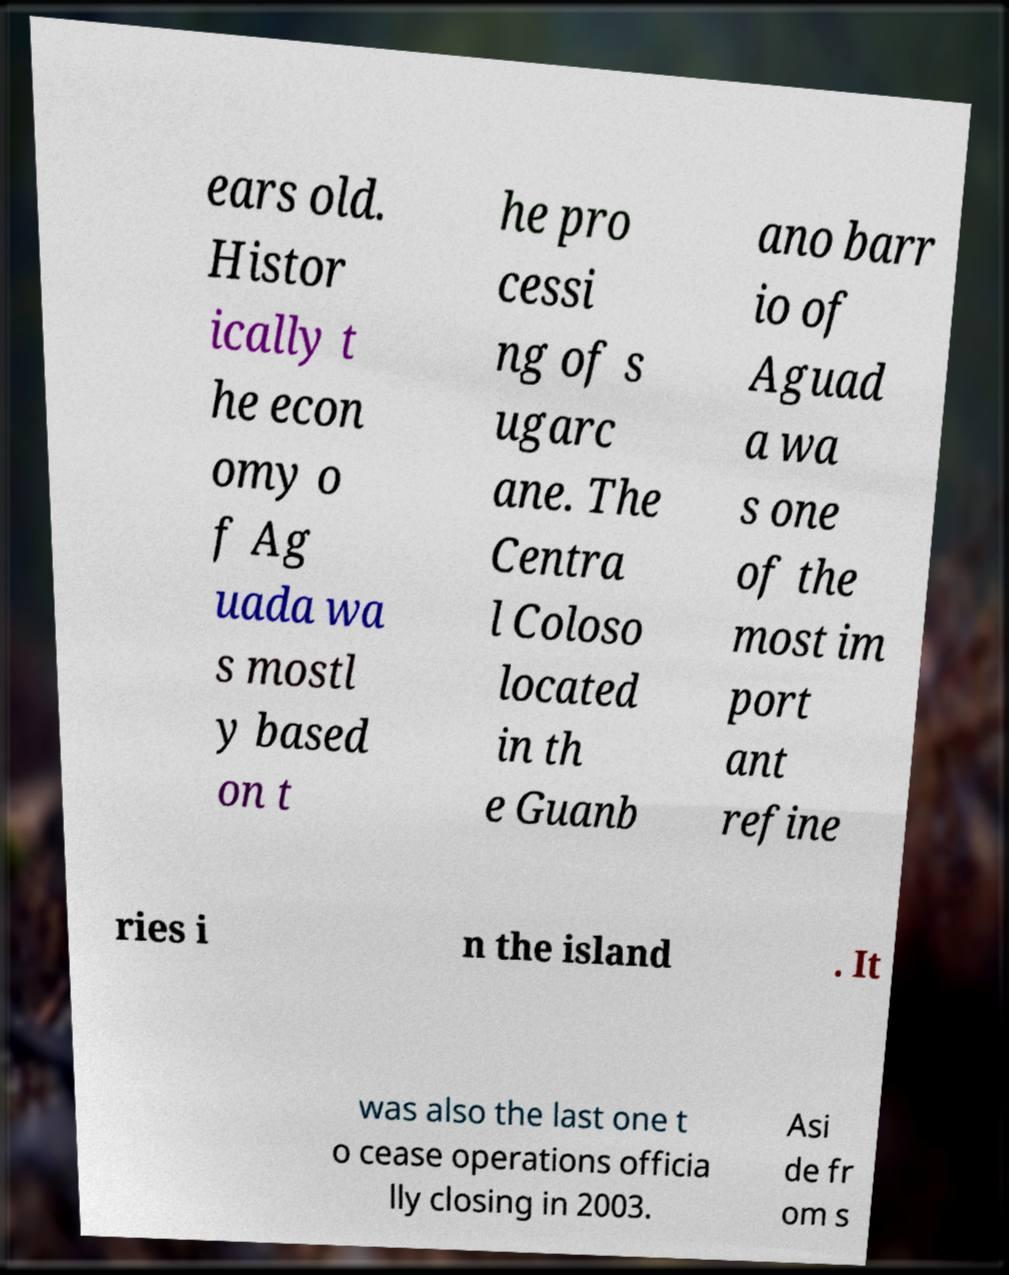Could you assist in decoding the text presented in this image and type it out clearly? ears old. Histor ically t he econ omy o f Ag uada wa s mostl y based on t he pro cessi ng of s ugarc ane. The Centra l Coloso located in th e Guanb ano barr io of Aguad a wa s one of the most im port ant refine ries i n the island . It was also the last one t o cease operations officia lly closing in 2003. Asi de fr om s 